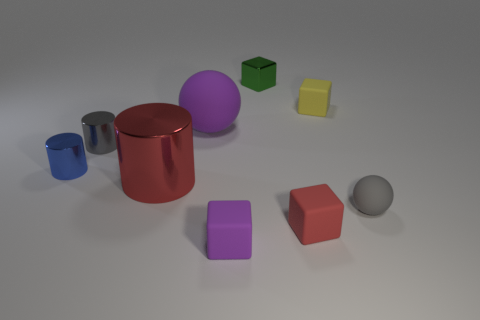Subtract all cubes. How many objects are left? 5 Add 1 yellow things. How many yellow things are left? 2 Add 6 small gray metallic cylinders. How many small gray metallic cylinders exist? 7 Subtract 0 yellow cylinders. How many objects are left? 9 Subtract all small purple rubber things. Subtract all green shiny objects. How many objects are left? 7 